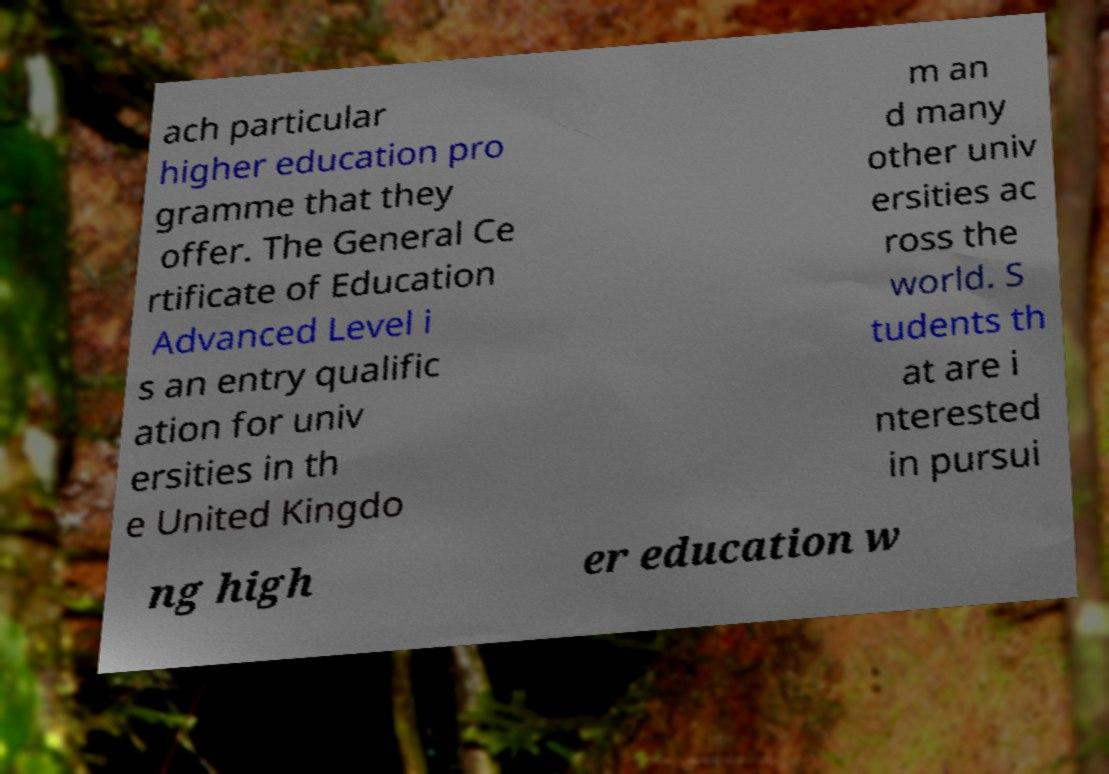Can you accurately transcribe the text from the provided image for me? ach particular higher education pro gramme that they offer. The General Ce rtificate of Education Advanced Level i s an entry qualific ation for univ ersities in th e United Kingdo m an d many other univ ersities ac ross the world. S tudents th at are i nterested in pursui ng high er education w 